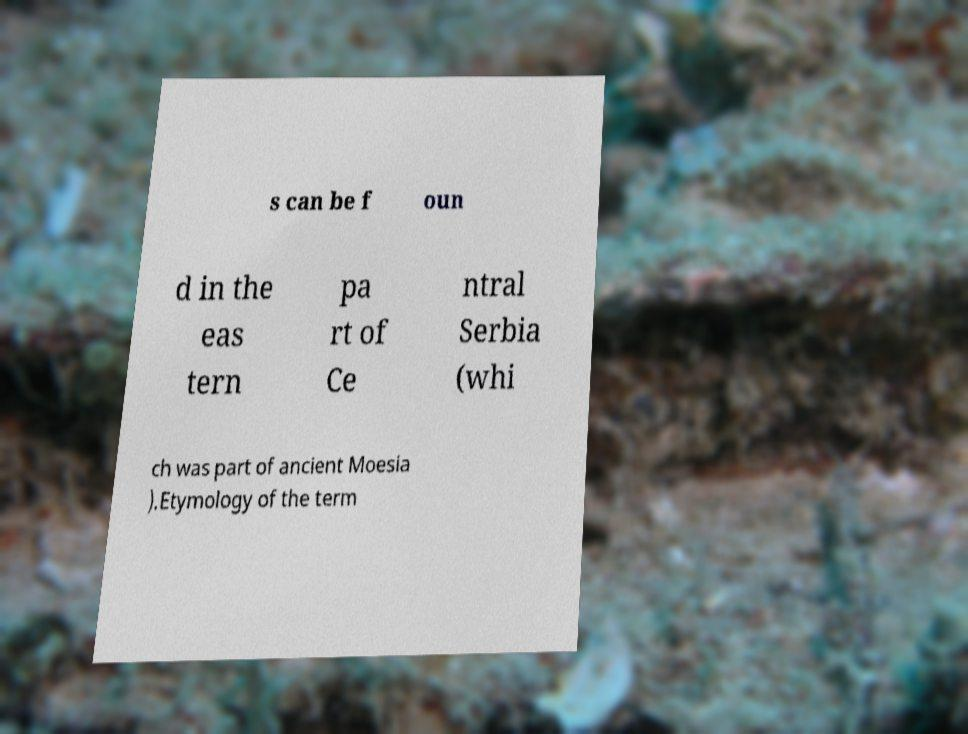What messages or text are displayed in this image? I need them in a readable, typed format. s can be f oun d in the eas tern pa rt of Ce ntral Serbia (whi ch was part of ancient Moesia ).Etymology of the term 